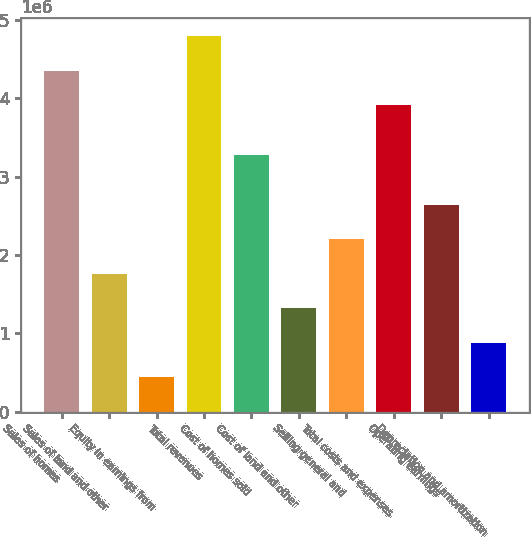Convert chart to OTSL. <chart><loc_0><loc_0><loc_500><loc_500><bar_chart><fcel>Sales of homes<fcel>Sales of land and other<fcel>Equity in earnings from<fcel>Total revenues<fcel>Cost of homes sold<fcel>Cost of land and other<fcel>Selling general and<fcel>Total costs and expenses<fcel>Operating earnings<fcel>Depreciation and amortization<nl><fcel>4.34766e+06<fcel>1.75948e+06<fcel>444204<fcel>4.78609e+06<fcel>3.27718e+06<fcel>1.32106e+06<fcel>2.19791e+06<fcel>3.90924e+06<fcel>2.63633e+06<fcel>882630<nl></chart> 